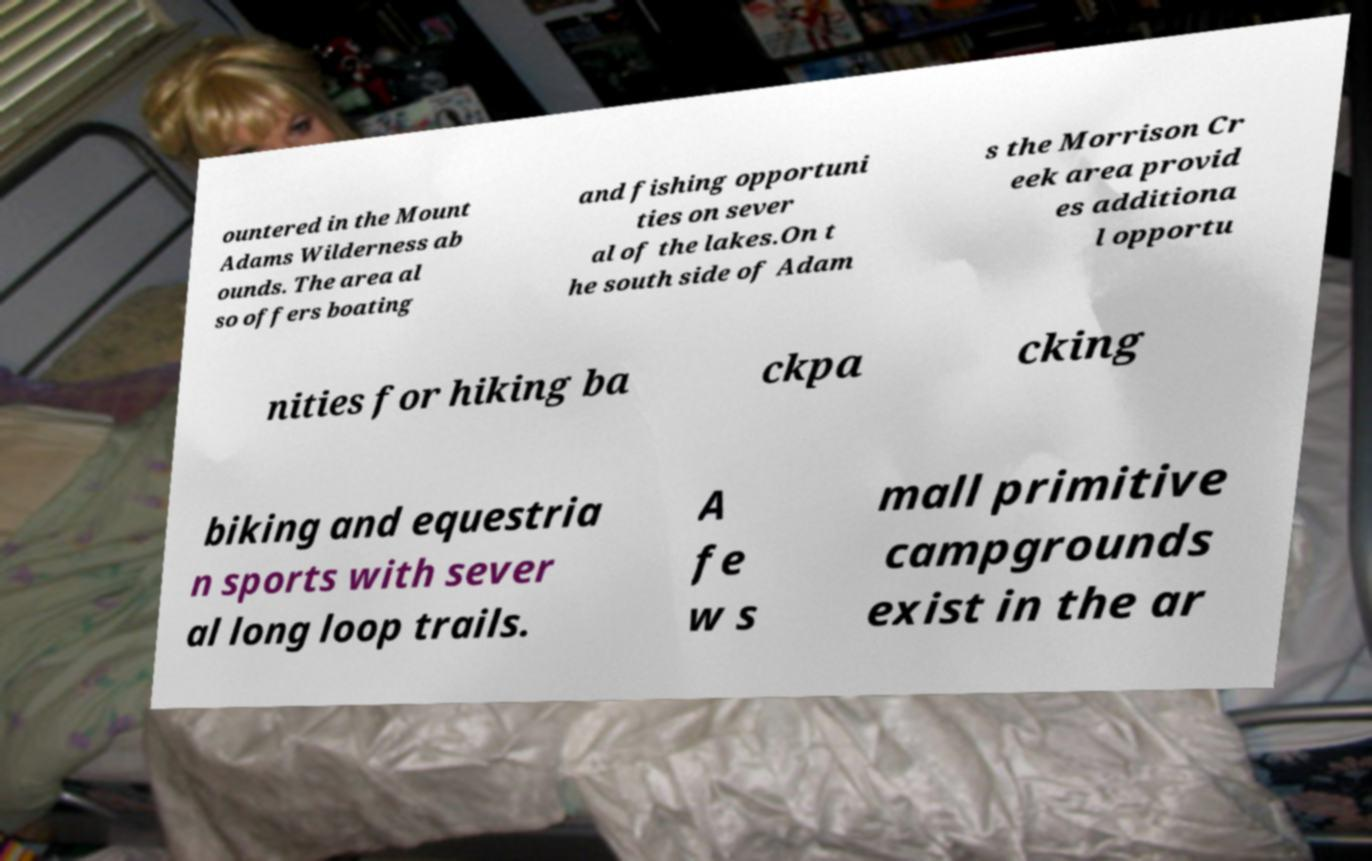For documentation purposes, I need the text within this image transcribed. Could you provide that? ountered in the Mount Adams Wilderness ab ounds. The area al so offers boating and fishing opportuni ties on sever al of the lakes.On t he south side of Adam s the Morrison Cr eek area provid es additiona l opportu nities for hiking ba ckpa cking biking and equestria n sports with sever al long loop trails. A fe w s mall primitive campgrounds exist in the ar 